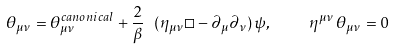<formula> <loc_0><loc_0><loc_500><loc_500>\theta _ { \mu \nu } = \theta ^ { c a n o n i c a l } _ { \mu \nu } + \frac { 2 } { \beta } \ ( \eta _ { \mu \nu } \Box - \partial _ { \mu } \partial _ { \nu } ) \, \psi , \quad \eta ^ { \mu \nu } \, \theta _ { \mu \nu } = 0</formula> 